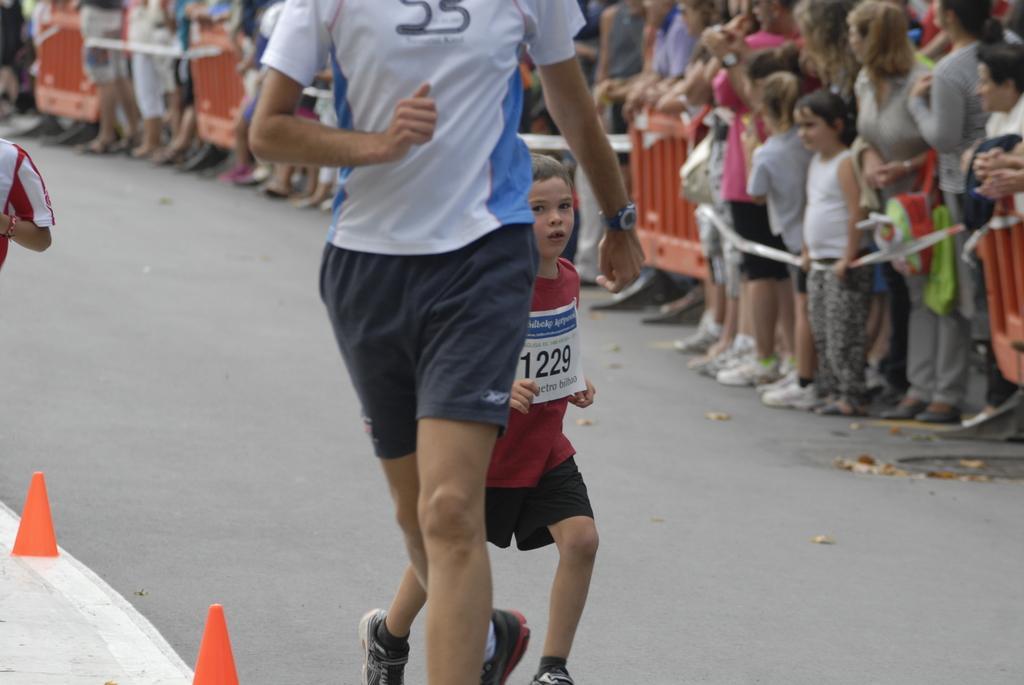How would you summarize this image in a sentence or two? In this picture we can see the man wearing a white t-shirt is walking on the track. Beside there is a small boy wearing red t-shirt is running. In the background is a group of men and women, standing and watching to the athletes. 